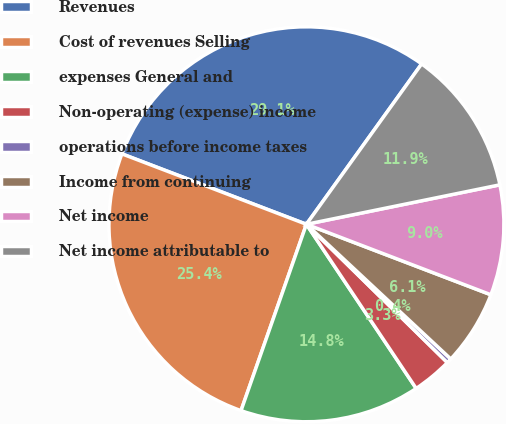Convert chart to OTSL. <chart><loc_0><loc_0><loc_500><loc_500><pie_chart><fcel>Revenues<fcel>Cost of revenues Selling<fcel>expenses General and<fcel>Non-operating (expense) income<fcel>operations before income taxes<fcel>Income from continuing<fcel>Net income<fcel>Net income attributable to<nl><fcel>29.11%<fcel>25.43%<fcel>14.75%<fcel>3.27%<fcel>0.4%<fcel>6.14%<fcel>9.01%<fcel>11.88%<nl></chart> 